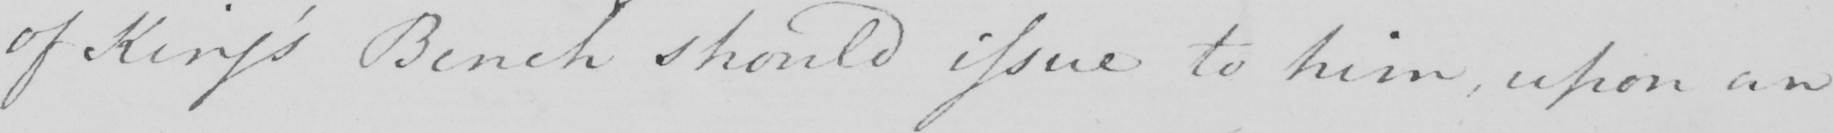What text is written in this handwritten line? of King ' s Bench should issue to him , upon an 